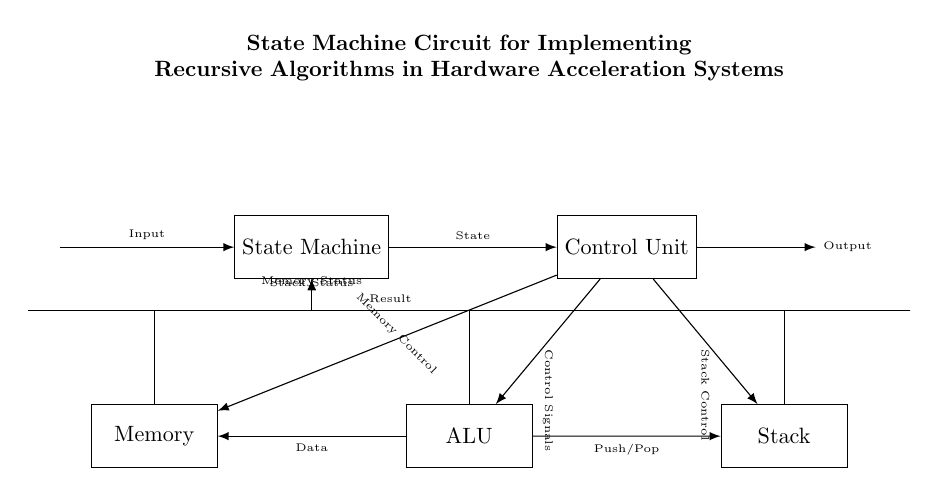What is the primary function of the state machine? The state machine orchestrates the operation of the control unit, which is essential for managing the sequence of operations in the circuit. It ensures that the various components execute their functions in the correct order to implement recursion effectively.
Answer: orchestration How many main components are in the circuit? The circuit consists of five main components: the state machine, control unit, ALU, memory, and stack. Each of these plays a crucial role in the overall operation and functionality of the circuit.
Answer: five What does the control unit primarily send to the ALU? The control unit primarily sends control signals to the ALU, dictating how it should perform operations and process data based on the current state and requirements of the algorithm being implemented.
Answer: control signals Which component is responsible for memory management? The control unit is responsible for managing memory through specific memory control signals sent to the memory component, directing read and write operations based on the algorithm's needs.
Answer: control unit How do the ALU and memory components interact in the circuit? The ALU and memory components interact by exchanging data; the ALU sends processed data to the memory for storage or retrieval, and it receives data from memory to perform calculations. This interaction is essential for implementing recursive algorithms.
Answer: data exchange What kind of recursive tasks does the stack handle? The stack handles push and pop operations, which are crucial for implementing recursive function calls by maintaining the state of each recursive call and enabling the return to previous states when necessary.
Answer: push/pop operations 